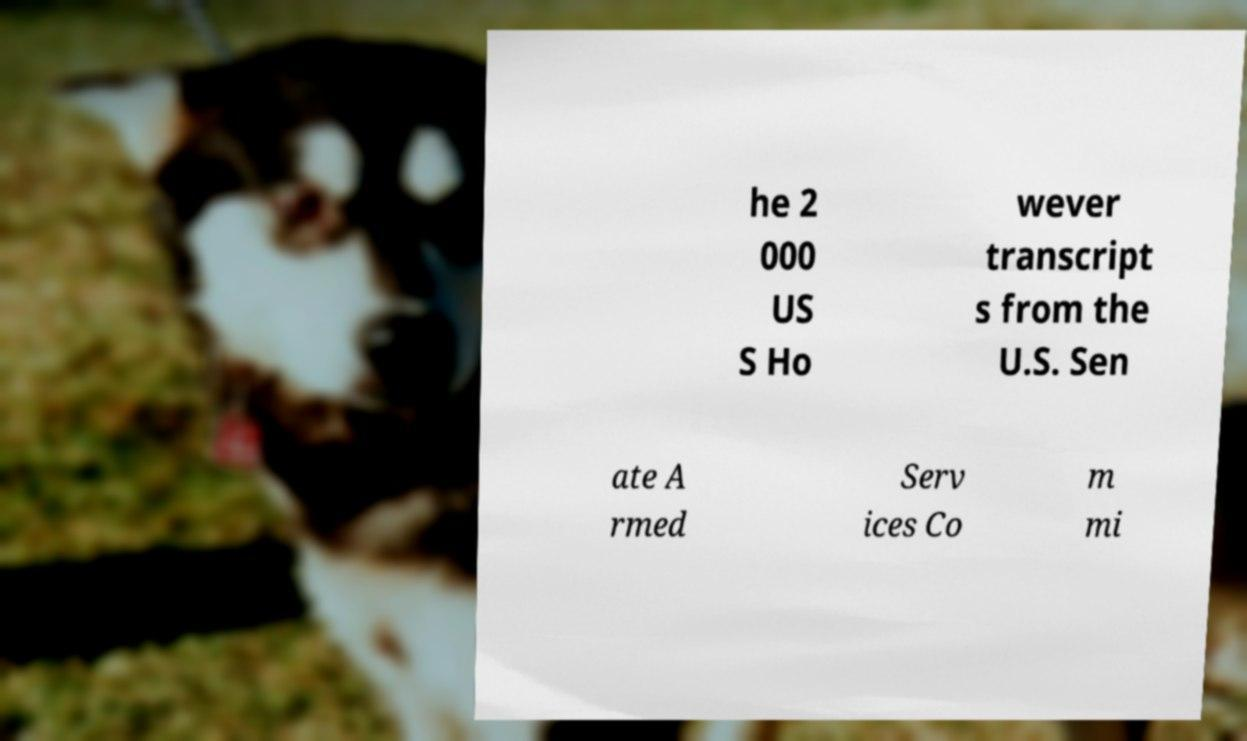Can you accurately transcribe the text from the provided image for me? he 2 000 US S Ho wever transcript s from the U.S. Sen ate A rmed Serv ices Co m mi 